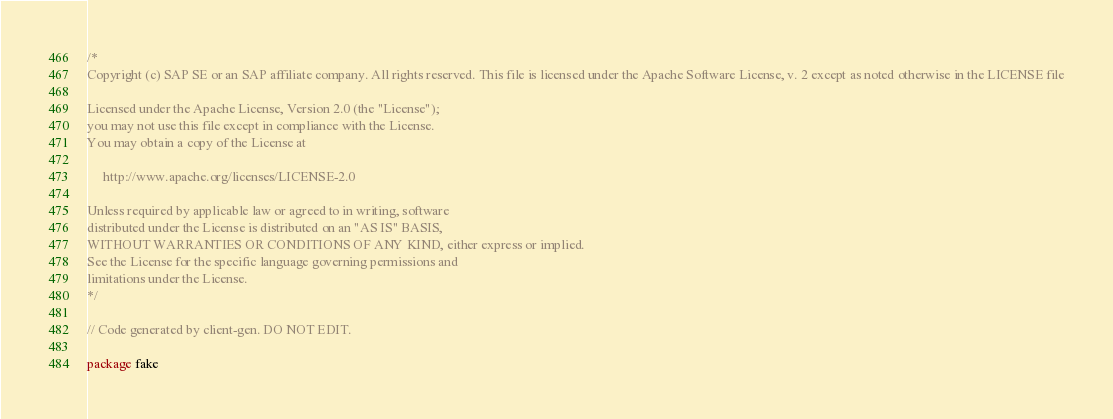<code> <loc_0><loc_0><loc_500><loc_500><_Go_>/*
Copyright (c) SAP SE or an SAP affiliate company. All rights reserved. This file is licensed under the Apache Software License, v. 2 except as noted otherwise in the LICENSE file

Licensed under the Apache License, Version 2.0 (the "License");
you may not use this file except in compliance with the License.
You may obtain a copy of the License at

     http://www.apache.org/licenses/LICENSE-2.0

Unless required by applicable law or agreed to in writing, software
distributed under the License is distributed on an "AS IS" BASIS,
WITHOUT WARRANTIES OR CONDITIONS OF ANY KIND, either express or implied.
See the License for the specific language governing permissions and
limitations under the License.
*/

// Code generated by client-gen. DO NOT EDIT.

package fake
</code> 